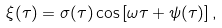<formula> <loc_0><loc_0><loc_500><loc_500>\xi ( \tau ) = \sigma ( \tau ) \cos { \left [ \omega \tau + \psi ( \tau ) \right ] } \, ,</formula> 